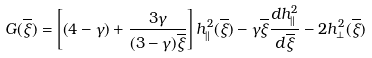<formula> <loc_0><loc_0><loc_500><loc_500>G ( \overline { \xi } ) = \left [ \left ( 4 - \gamma \right ) + \frac { 3 \gamma } { ( 3 - \gamma ) \overline { \xi } } \right ] h ^ { 2 } _ { \| } ( \overline { \xi } ) - \gamma \overline { \xi } \frac { d h ^ { 2 } _ { \| } } { d \overline { \xi } } - 2 h ^ { 2 } _ { \perp } ( \overline { \xi } )</formula> 